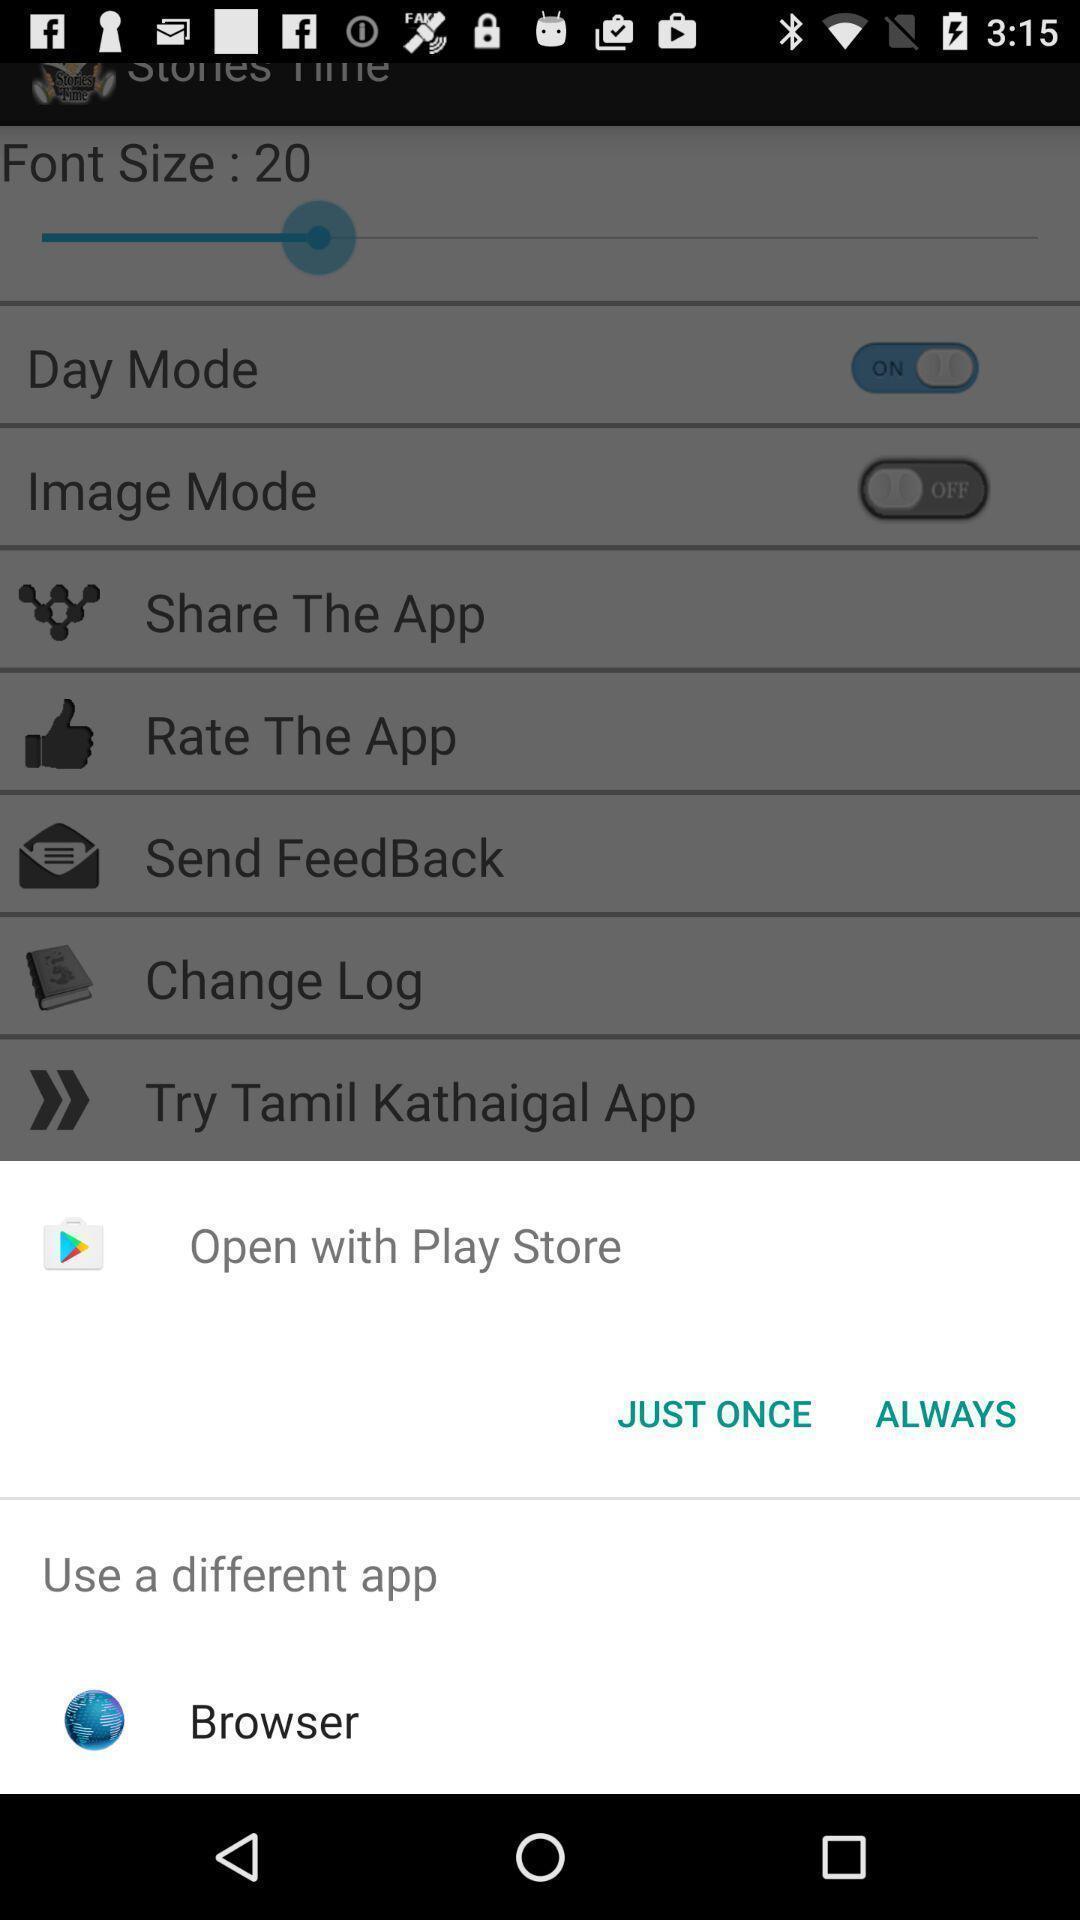Summarize the main components in this picture. Popup displaying different options for opening in a story application. 